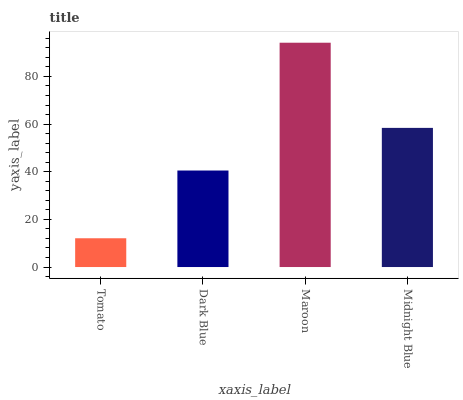Is Dark Blue the minimum?
Answer yes or no. No. Is Dark Blue the maximum?
Answer yes or no. No. Is Dark Blue greater than Tomato?
Answer yes or no. Yes. Is Tomato less than Dark Blue?
Answer yes or no. Yes. Is Tomato greater than Dark Blue?
Answer yes or no. No. Is Dark Blue less than Tomato?
Answer yes or no. No. Is Midnight Blue the high median?
Answer yes or no. Yes. Is Dark Blue the low median?
Answer yes or no. Yes. Is Dark Blue the high median?
Answer yes or no. No. Is Midnight Blue the low median?
Answer yes or no. No. 